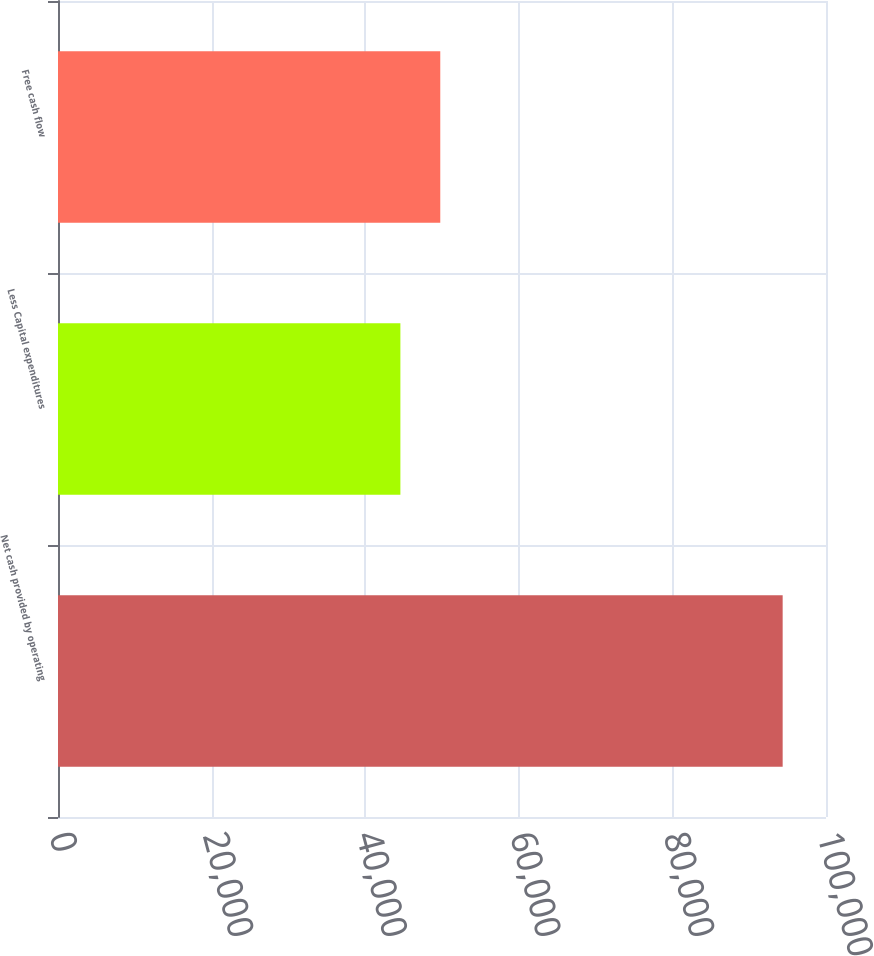<chart> <loc_0><loc_0><loc_500><loc_500><bar_chart><fcel>Net cash provided by operating<fcel>Less Capital expenditures<fcel>Free cash flow<nl><fcel>94357<fcel>44582<fcel>49775<nl></chart> 